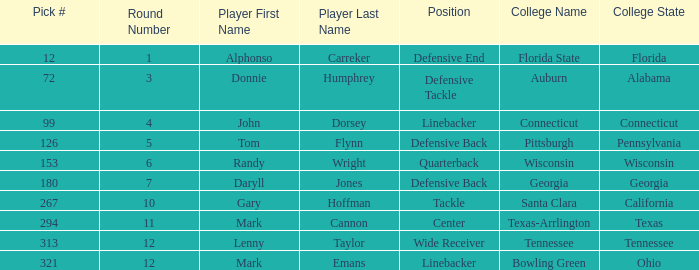In which round was an athlete from college of connecticut drafted? Round 4. 